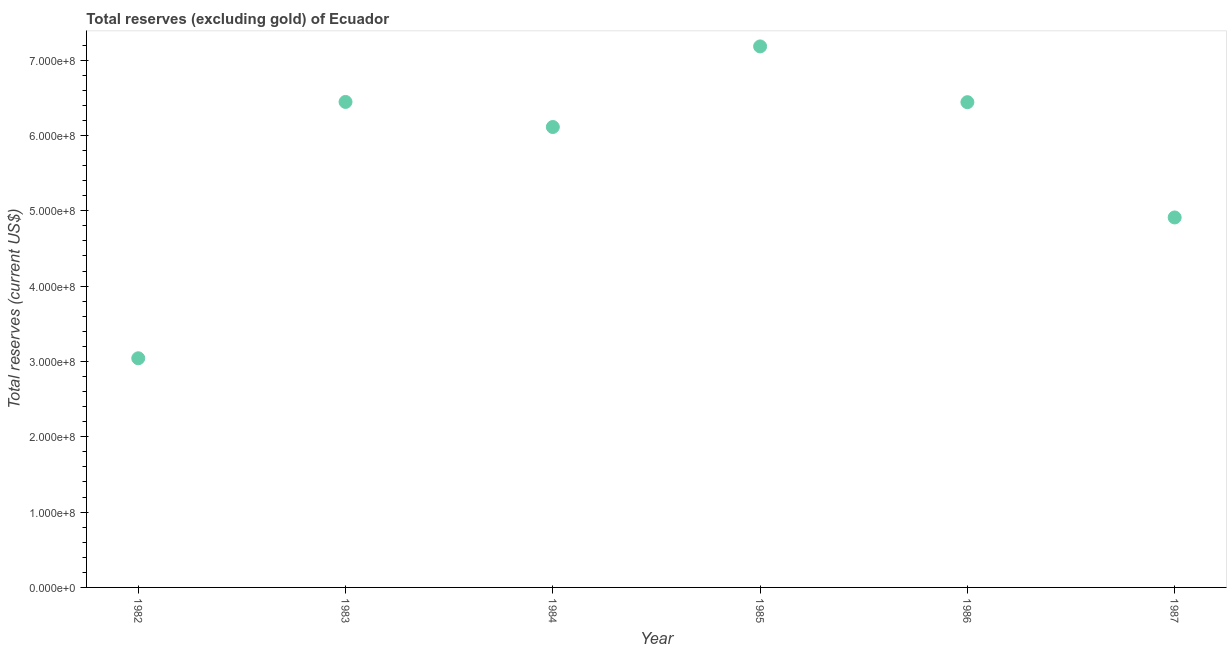What is the total reserves (excluding gold) in 1987?
Provide a succinct answer. 4.91e+08. Across all years, what is the maximum total reserves (excluding gold)?
Provide a succinct answer. 7.18e+08. Across all years, what is the minimum total reserves (excluding gold)?
Provide a short and direct response. 3.04e+08. In which year was the total reserves (excluding gold) minimum?
Provide a short and direct response. 1982. What is the sum of the total reserves (excluding gold)?
Ensure brevity in your answer.  3.41e+09. What is the difference between the total reserves (excluding gold) in 1983 and 1987?
Your response must be concise. 1.53e+08. What is the average total reserves (excluding gold) per year?
Your response must be concise. 5.69e+08. What is the median total reserves (excluding gold)?
Provide a short and direct response. 6.28e+08. In how many years, is the total reserves (excluding gold) greater than 60000000 US$?
Make the answer very short. 6. What is the ratio of the total reserves (excluding gold) in 1983 to that in 1984?
Ensure brevity in your answer.  1.05. Is the total reserves (excluding gold) in 1983 less than that in 1986?
Offer a terse response. No. Is the difference between the total reserves (excluding gold) in 1984 and 1987 greater than the difference between any two years?
Ensure brevity in your answer.  No. What is the difference between the highest and the second highest total reserves (excluding gold)?
Make the answer very short. 7.37e+07. Is the sum of the total reserves (excluding gold) in 1984 and 1985 greater than the maximum total reserves (excluding gold) across all years?
Offer a terse response. Yes. What is the difference between the highest and the lowest total reserves (excluding gold)?
Your response must be concise. 4.14e+08. In how many years, is the total reserves (excluding gold) greater than the average total reserves (excluding gold) taken over all years?
Provide a short and direct response. 4. Does the total reserves (excluding gold) monotonically increase over the years?
Your response must be concise. No. How many dotlines are there?
Keep it short and to the point. 1. How many years are there in the graph?
Offer a terse response. 6. Are the values on the major ticks of Y-axis written in scientific E-notation?
Ensure brevity in your answer.  Yes. Does the graph contain any zero values?
Offer a terse response. No. Does the graph contain grids?
Offer a very short reply. No. What is the title of the graph?
Offer a very short reply. Total reserves (excluding gold) of Ecuador. What is the label or title of the Y-axis?
Provide a succinct answer. Total reserves (current US$). What is the Total reserves (current US$) in 1982?
Give a very brief answer. 3.04e+08. What is the Total reserves (current US$) in 1983?
Give a very brief answer. 6.44e+08. What is the Total reserves (current US$) in 1984?
Your answer should be compact. 6.11e+08. What is the Total reserves (current US$) in 1985?
Give a very brief answer. 7.18e+08. What is the Total reserves (current US$) in 1986?
Keep it short and to the point. 6.44e+08. What is the Total reserves (current US$) in 1987?
Your response must be concise. 4.91e+08. What is the difference between the Total reserves (current US$) in 1982 and 1983?
Provide a short and direct response. -3.40e+08. What is the difference between the Total reserves (current US$) in 1982 and 1984?
Your response must be concise. -3.07e+08. What is the difference between the Total reserves (current US$) in 1982 and 1985?
Offer a terse response. -4.14e+08. What is the difference between the Total reserves (current US$) in 1982 and 1986?
Ensure brevity in your answer.  -3.40e+08. What is the difference between the Total reserves (current US$) in 1982 and 1987?
Your answer should be compact. -1.87e+08. What is the difference between the Total reserves (current US$) in 1983 and 1984?
Give a very brief answer. 3.33e+07. What is the difference between the Total reserves (current US$) in 1983 and 1985?
Your response must be concise. -7.37e+07. What is the difference between the Total reserves (current US$) in 1983 and 1986?
Make the answer very short. 3.23e+05. What is the difference between the Total reserves (current US$) in 1983 and 1987?
Offer a very short reply. 1.53e+08. What is the difference between the Total reserves (current US$) in 1984 and 1985?
Keep it short and to the point. -1.07e+08. What is the difference between the Total reserves (current US$) in 1984 and 1986?
Your answer should be very brief. -3.30e+07. What is the difference between the Total reserves (current US$) in 1984 and 1987?
Keep it short and to the point. 1.20e+08. What is the difference between the Total reserves (current US$) in 1985 and 1986?
Your answer should be very brief. 7.40e+07. What is the difference between the Total reserves (current US$) in 1985 and 1987?
Ensure brevity in your answer.  2.27e+08. What is the difference between the Total reserves (current US$) in 1986 and 1987?
Keep it short and to the point. 1.53e+08. What is the ratio of the Total reserves (current US$) in 1982 to that in 1983?
Provide a short and direct response. 0.47. What is the ratio of the Total reserves (current US$) in 1982 to that in 1984?
Keep it short and to the point. 0.5. What is the ratio of the Total reserves (current US$) in 1982 to that in 1985?
Provide a short and direct response. 0.42. What is the ratio of the Total reserves (current US$) in 1982 to that in 1986?
Ensure brevity in your answer.  0.47. What is the ratio of the Total reserves (current US$) in 1982 to that in 1987?
Give a very brief answer. 0.62. What is the ratio of the Total reserves (current US$) in 1983 to that in 1984?
Offer a terse response. 1.05. What is the ratio of the Total reserves (current US$) in 1983 to that in 1985?
Keep it short and to the point. 0.9. What is the ratio of the Total reserves (current US$) in 1983 to that in 1987?
Your answer should be compact. 1.31. What is the ratio of the Total reserves (current US$) in 1984 to that in 1985?
Your answer should be compact. 0.85. What is the ratio of the Total reserves (current US$) in 1984 to that in 1986?
Offer a very short reply. 0.95. What is the ratio of the Total reserves (current US$) in 1984 to that in 1987?
Make the answer very short. 1.24. What is the ratio of the Total reserves (current US$) in 1985 to that in 1986?
Provide a succinct answer. 1.11. What is the ratio of the Total reserves (current US$) in 1985 to that in 1987?
Your answer should be compact. 1.46. What is the ratio of the Total reserves (current US$) in 1986 to that in 1987?
Provide a short and direct response. 1.31. 